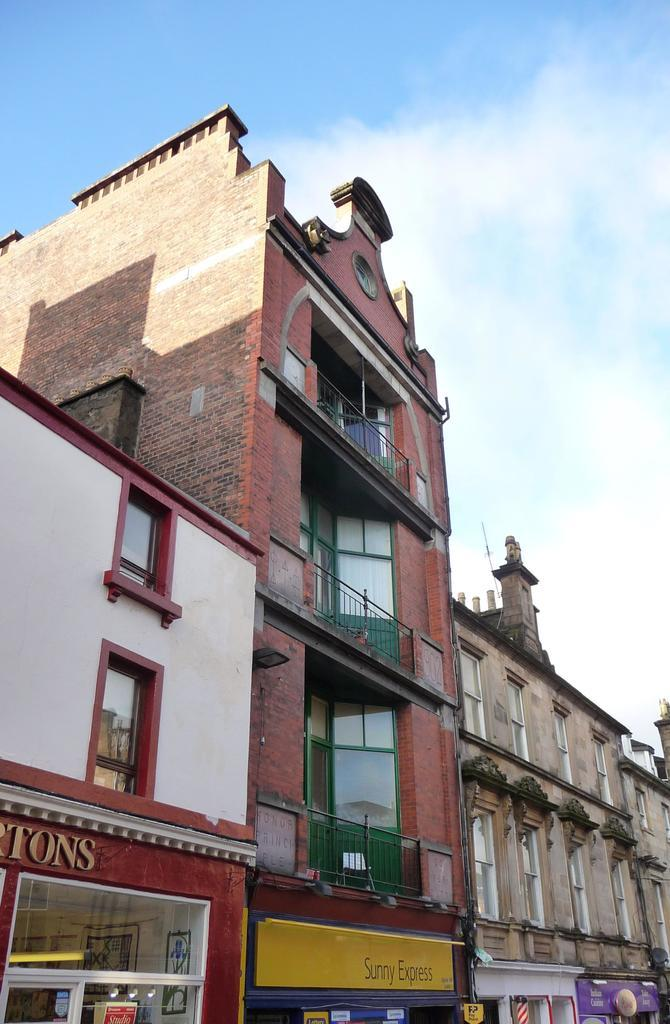What type of structures are visible in the image? There are buildings in the image. What feature do the buildings have? The buildings have windows. What can be seen on the walls of the buildings? There are hoardings on the walls of the buildings. What is visible in the sky in the background of the image? There are clouds in the sky in the background of the image. What type of ink is used to write on the hoardings in the image? There is no indication of any writing on the hoardings in the image, so it is not possible to determine the type of ink used. 